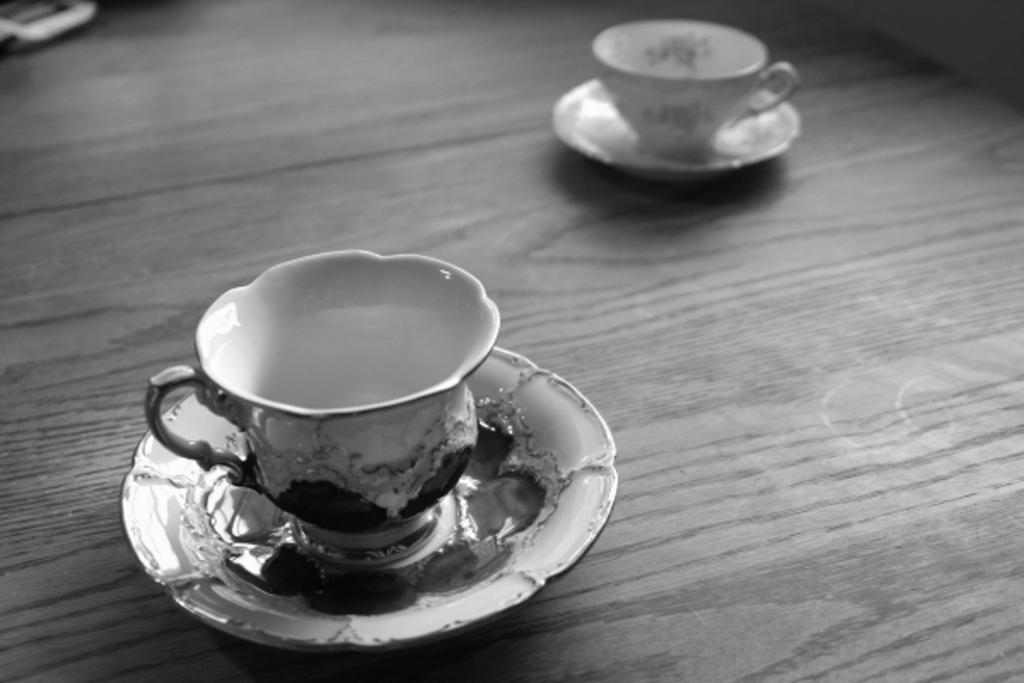What type of beverage is in the cups in the image? There are cups of tea in the image. What is on the plate in the image? The facts do not specify what is on the plate. What color is the floor in the image? The floor is brown in color. How does the paste drop onto the floor in the image? There is no paste or dropping action present in the image. 